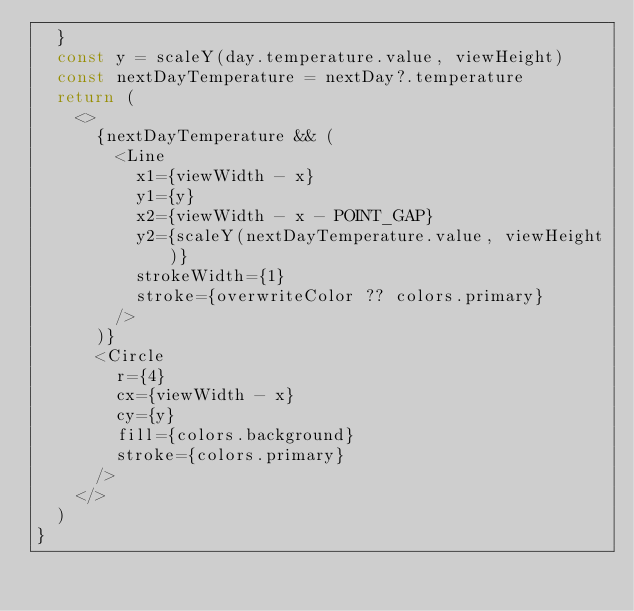Convert code to text. <code><loc_0><loc_0><loc_500><loc_500><_TypeScript_>  }
  const y = scaleY(day.temperature.value, viewHeight)
  const nextDayTemperature = nextDay?.temperature
  return (
    <>
      {nextDayTemperature && (
        <Line
          x1={viewWidth - x}
          y1={y}
          x2={viewWidth - x - POINT_GAP}
          y2={scaleY(nextDayTemperature.value, viewHeight)}
          strokeWidth={1}
          stroke={overwriteColor ?? colors.primary}
        />
      )}
      <Circle
        r={4}
        cx={viewWidth - x}
        cy={y}
        fill={colors.background}
        stroke={colors.primary}
      />
    </>
  )
}
</code> 